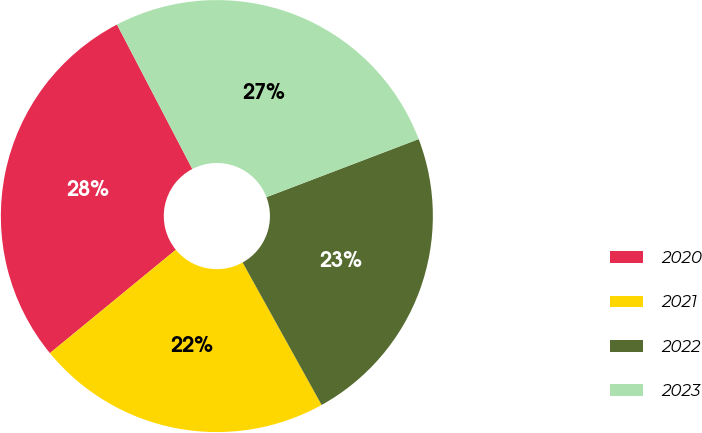<chart> <loc_0><loc_0><loc_500><loc_500><pie_chart><fcel>2020<fcel>2021<fcel>2022<fcel>2023<nl><fcel>28.29%<fcel>22.12%<fcel>22.74%<fcel>26.85%<nl></chart> 